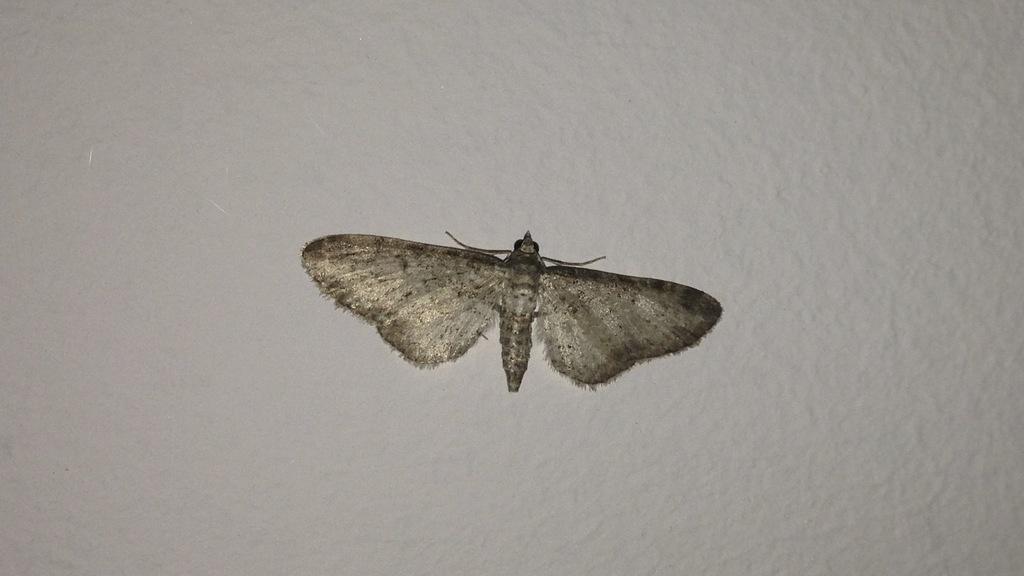In one or two sentences, can you explain what this image depicts? In this image I can see an insect in brown and gray color and I can see the white color background. 